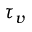<formula> <loc_0><loc_0><loc_500><loc_500>\tau _ { v }</formula> 